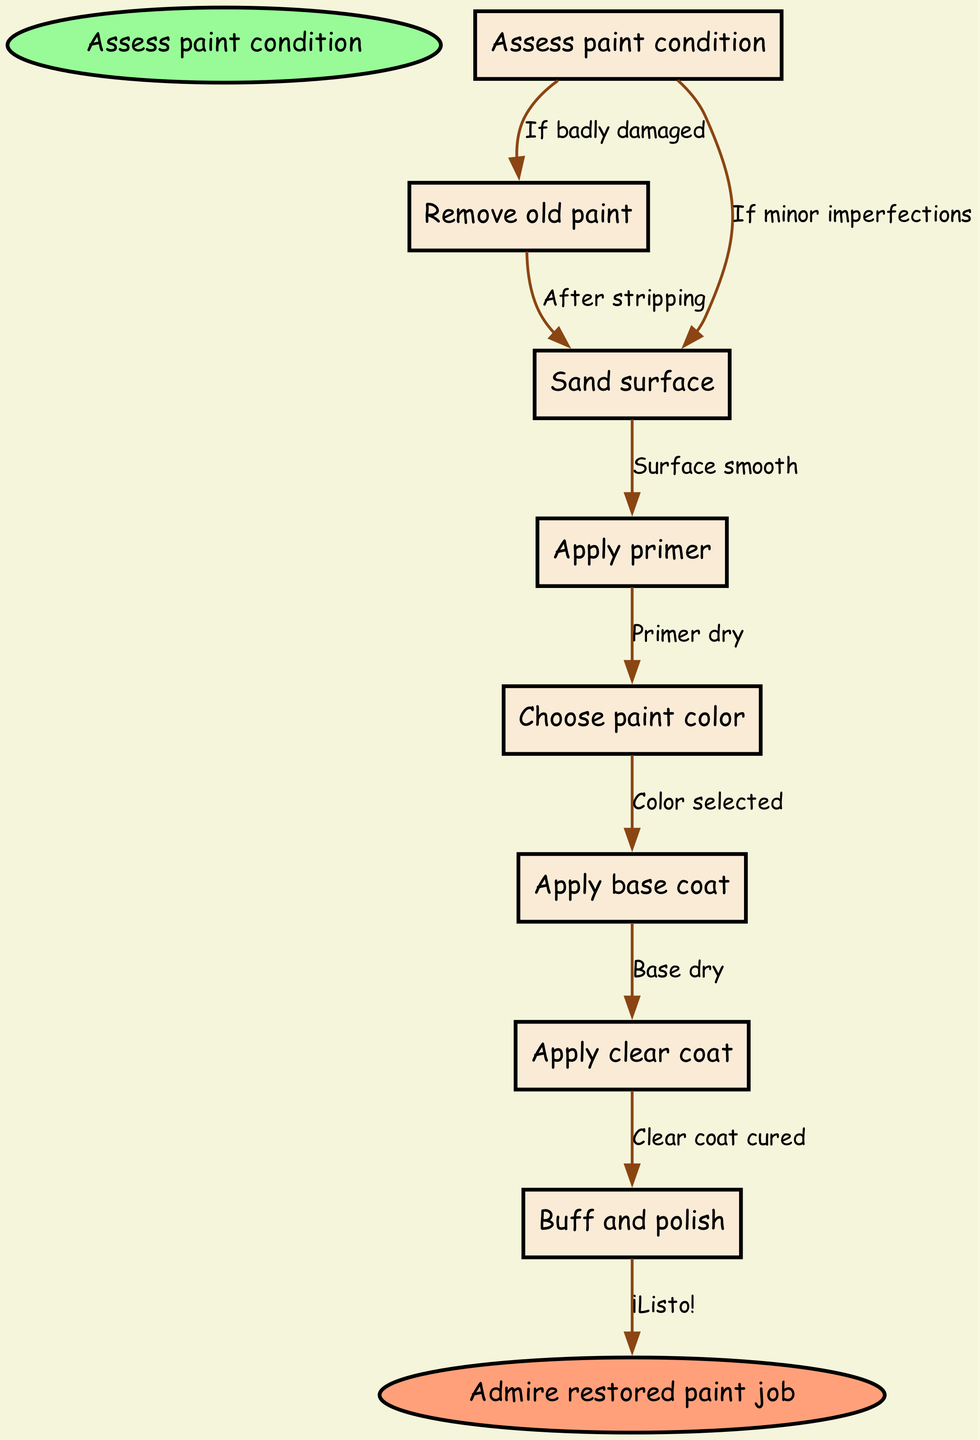What is the starting point of the flowchart? The starting point of the flowchart is specified as "Assess paint condition." This is indicated as the first node where the process begins.
Answer: Assess paint condition How many nodes are in the flowchart? The flowchart includes a total of 8 nodes: 1 start node, 6 intermediate nodes, and 1 end node. Counting all of them confirms the total.
Answer: 8 What is the last step before admiring the restored paint job? The last step before reaching the end node "Admire restored paint job" is "Buff and polish." This is the final task in the series of actions before one can appreciate the restoration.
Answer: Buff and polish What step follows after applying the primer? After applying the primer, the next step is to "Choose paint color." This shows that selecting the color is contingent upon the primer being dry.
Answer: Choose paint color If the paint condition shows minor imperfections, which step is taken? If the paint condition shows minor imperfections, the flowchart directs us to "Sand surface" as the next step, highlighting that there is no need to remove old paint in this scenario.
Answer: Sand surface How is the flow from "Remove old paint" to "Sand surface" labeled? The flow from "Remove old paint" to "Sand surface" is labeled "After stripping," indicating that sanding is the next action taken after the old paint has been completely removed.
Answer: After stripping What is the label for the edge from "Apply clear coat" to "Buff and polish"? The label for the edge from "Apply clear coat" to "Buff and polish" is "Clear coat cured." This implies that buffing and polishing should only occur once the clear coat has fully cured.
Answer: Clear coat cured Which step occurs after the base coat is dry? The step following the drying of the base coat is "Apply clear coat." This is a sequential process where each step depends on the completion of the previous one.
Answer: Apply clear coat 